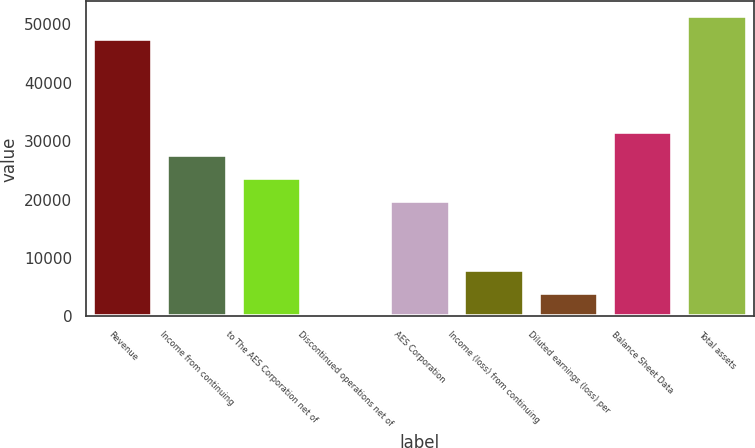Convert chart. <chart><loc_0><loc_0><loc_500><loc_500><bar_chart><fcel>Revenue<fcel>Income from continuing<fcel>to The AES Corporation net of<fcel>Discontinued operations net of<fcel>AES Corporation<fcel>Income (loss) from continuing<fcel>Diluted earnings (loss) per<fcel>Balance Sheet Data<fcel>Total assets<nl><fcel>47441.9<fcel>27674.5<fcel>23721<fcel>0.07<fcel>19767.5<fcel>7907.05<fcel>3953.56<fcel>31628<fcel>51395.4<nl></chart> 